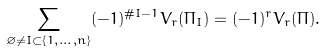<formula> <loc_0><loc_0><loc_500><loc_500>\sum _ { \varnothing \neq I \subset \{ 1 , \dots , n \} } ( - 1 ) ^ { \# I - 1 } V _ { r } ( \Pi _ { I } ) = ( - 1 ) ^ { r } V _ { r } ( \Pi ) .</formula> 